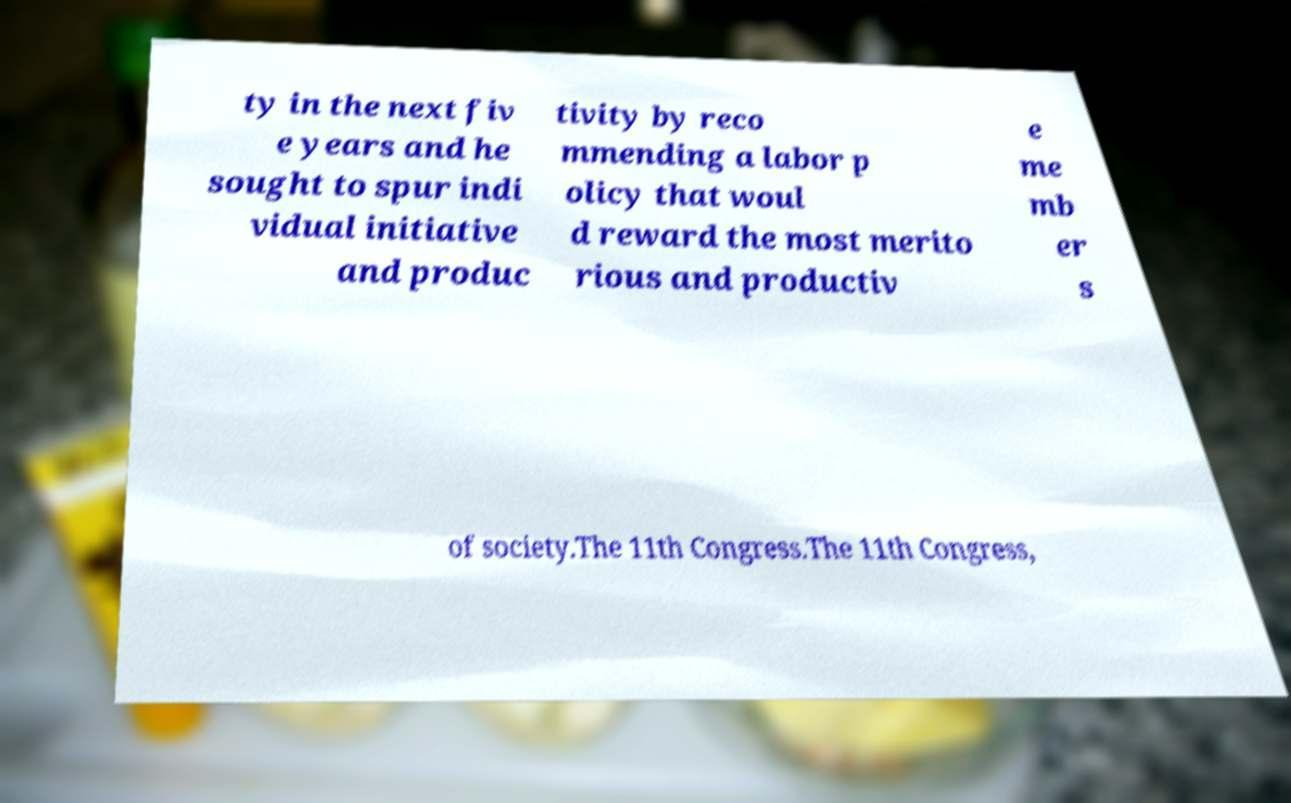Can you accurately transcribe the text from the provided image for me? ty in the next fiv e years and he sought to spur indi vidual initiative and produc tivity by reco mmending a labor p olicy that woul d reward the most merito rious and productiv e me mb er s of society.The 11th Congress.The 11th Congress, 